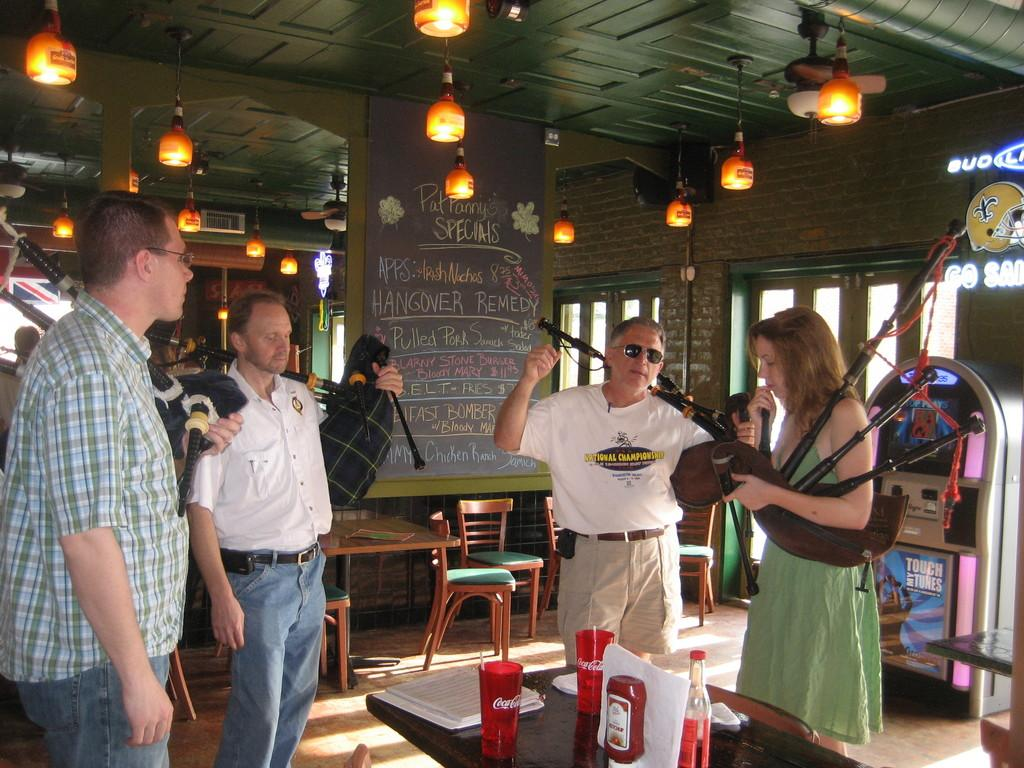What are the persons in the image doing? The persons in the image are holding sticks. What is on top of the sticks? There are lights on top of the sticks. What can be seen through the windows in the image? The details of what can be seen through the windows are not provided in the facts. What objects are on the table in the image? There are cups, books, and bottles on the table in the image. What type of furniture is present in the image? There are chairs and tables in the image. What type of family is depicted in the image? There is no mention of a family in the image; the facts only mention persons holding sticks with lights on top. What type of band is performing in the image? There is no mention of a band or any musical performance in the image; the facts only mention persons holding sticks with lights on top. 